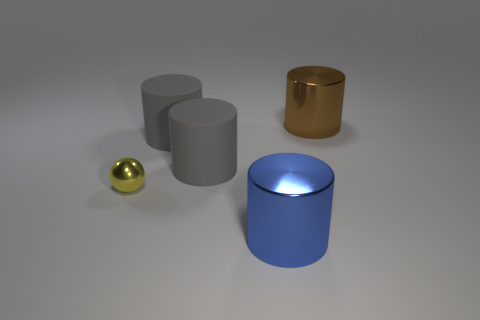Do the yellow metallic sphere and the blue shiny cylinder have the same size?
Offer a terse response. No. What number of things are large shiny cylinders to the left of the brown shiny cylinder or big things in front of the tiny yellow metallic ball?
Provide a succinct answer. 1. Is the number of big matte cylinders in front of the yellow object greater than the number of brown cylinders?
Your answer should be very brief. No. How many other objects are the same shape as the brown object?
Your answer should be very brief. 3. What number of things are either big cyan balls or big brown shiny things?
Provide a short and direct response. 1. Are there more purple cylinders than gray rubber cylinders?
Your answer should be compact. No. What size is the metallic cylinder that is behind the large cylinder that is in front of the yellow object?
Offer a very short reply. Large. What is the color of the other metallic thing that is the same shape as the brown shiny thing?
Your response must be concise. Blue. How big is the yellow sphere?
Your answer should be very brief. Small. How many cylinders are either small red things or large brown things?
Your answer should be compact. 1. 